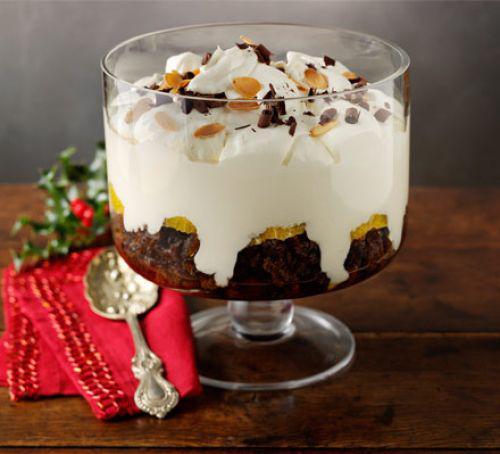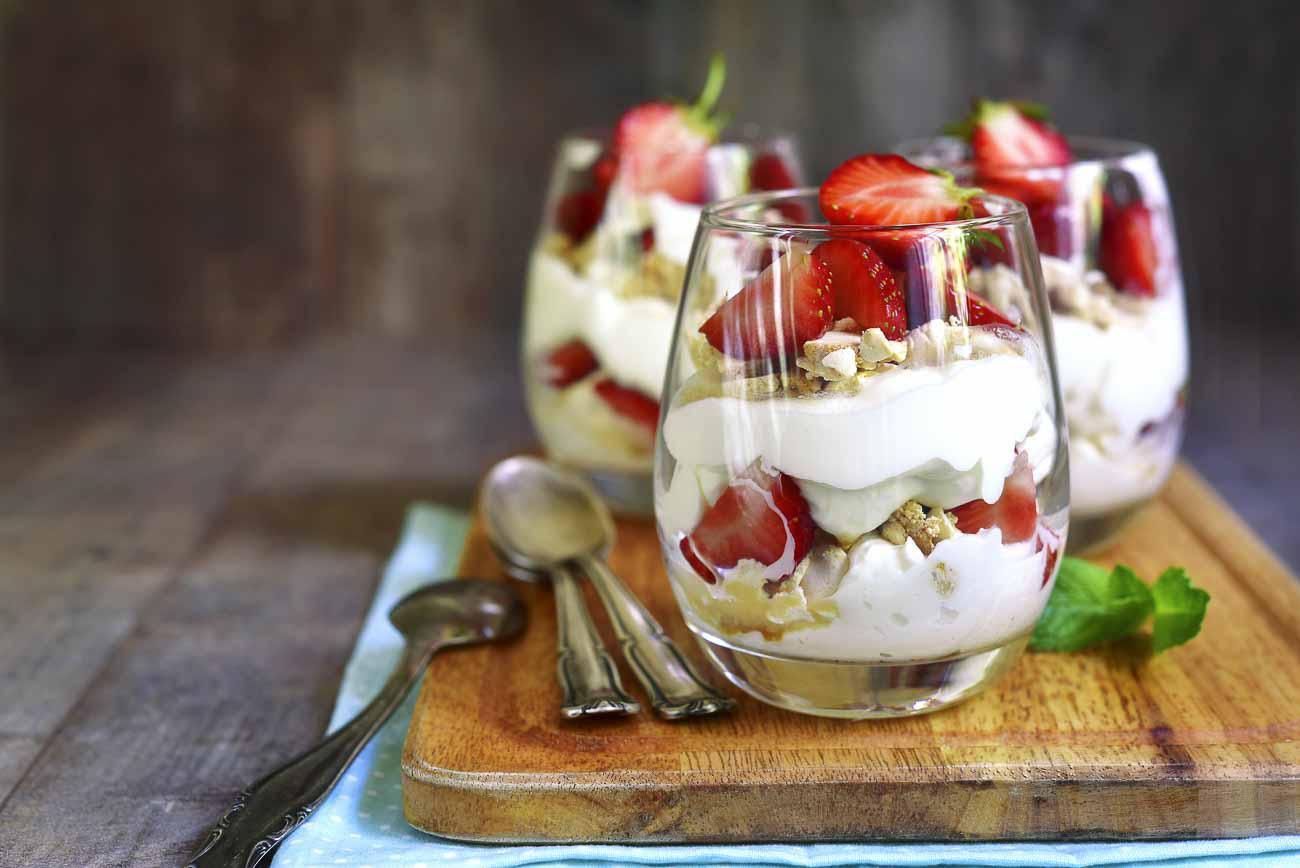The first image is the image on the left, the second image is the image on the right. Considering the images on both sides, is "A trifle is garnished with pomegranite seeds arranged in a spoke pattern." valid? Answer yes or no. No. 